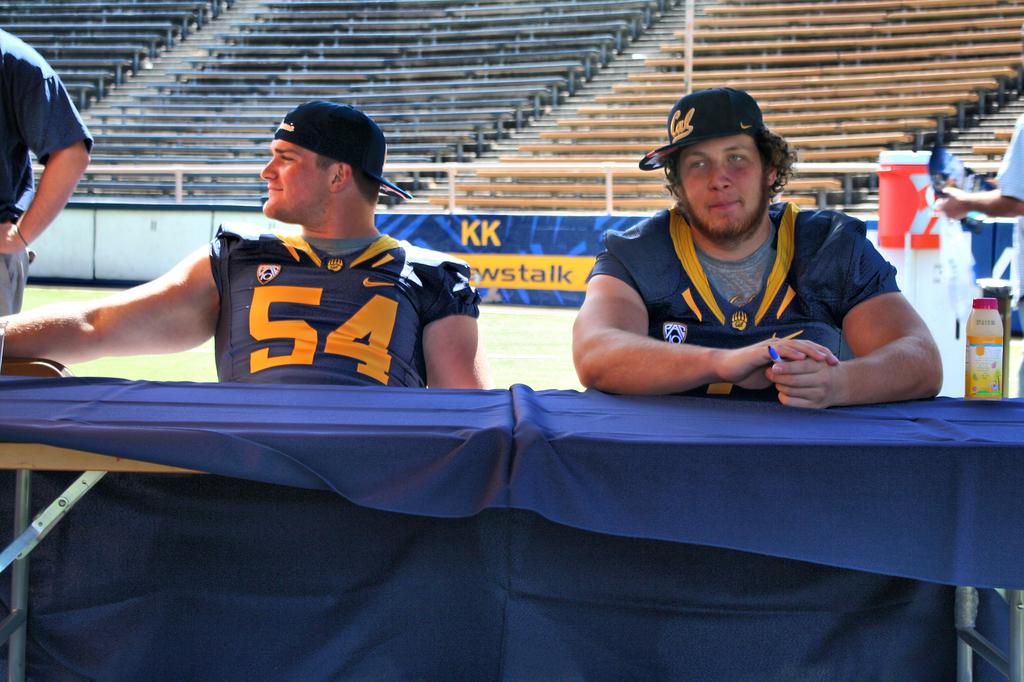What number does the player on the left wear?
Provide a short and direct response. 54. What is the guy's jersey number on the left?
Your answer should be very brief. 54. 